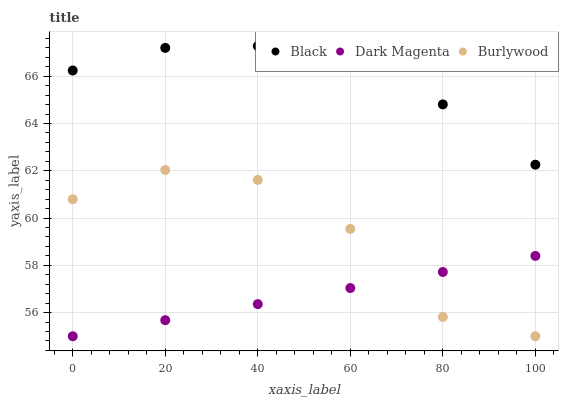Does Dark Magenta have the minimum area under the curve?
Answer yes or no. Yes. Does Black have the maximum area under the curve?
Answer yes or no. Yes. Does Black have the minimum area under the curve?
Answer yes or no. No. Does Dark Magenta have the maximum area under the curve?
Answer yes or no. No. Is Dark Magenta the smoothest?
Answer yes or no. Yes. Is Burlywood the roughest?
Answer yes or no. Yes. Is Black the smoothest?
Answer yes or no. No. Is Black the roughest?
Answer yes or no. No. Does Burlywood have the lowest value?
Answer yes or no. Yes. Does Black have the lowest value?
Answer yes or no. No. Does Black have the highest value?
Answer yes or no. Yes. Does Dark Magenta have the highest value?
Answer yes or no. No. Is Burlywood less than Black?
Answer yes or no. Yes. Is Black greater than Dark Magenta?
Answer yes or no. Yes. Does Burlywood intersect Dark Magenta?
Answer yes or no. Yes. Is Burlywood less than Dark Magenta?
Answer yes or no. No. Is Burlywood greater than Dark Magenta?
Answer yes or no. No. Does Burlywood intersect Black?
Answer yes or no. No. 